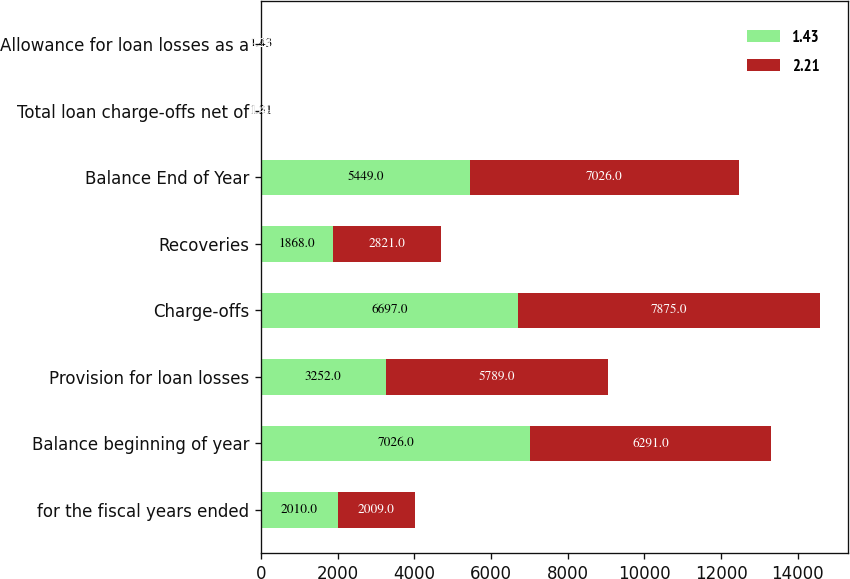Convert chart to OTSL. <chart><loc_0><loc_0><loc_500><loc_500><stacked_bar_chart><ecel><fcel>for the fiscal years ended<fcel>Balance beginning of year<fcel>Provision for loan losses<fcel>Charge-offs<fcel>Recoveries<fcel>Balance End of Year<fcel>Total loan charge-offs net of<fcel>Allowance for loan losses as a<nl><fcel>1.43<fcel>2010<fcel>7026<fcel>3252<fcel>6697<fcel>1868<fcel>5449<fcel>1.31<fcel>1.43<nl><fcel>2.21<fcel>2009<fcel>6291<fcel>5789<fcel>7875<fcel>2821<fcel>7026<fcel>1.49<fcel>2.21<nl></chart> 